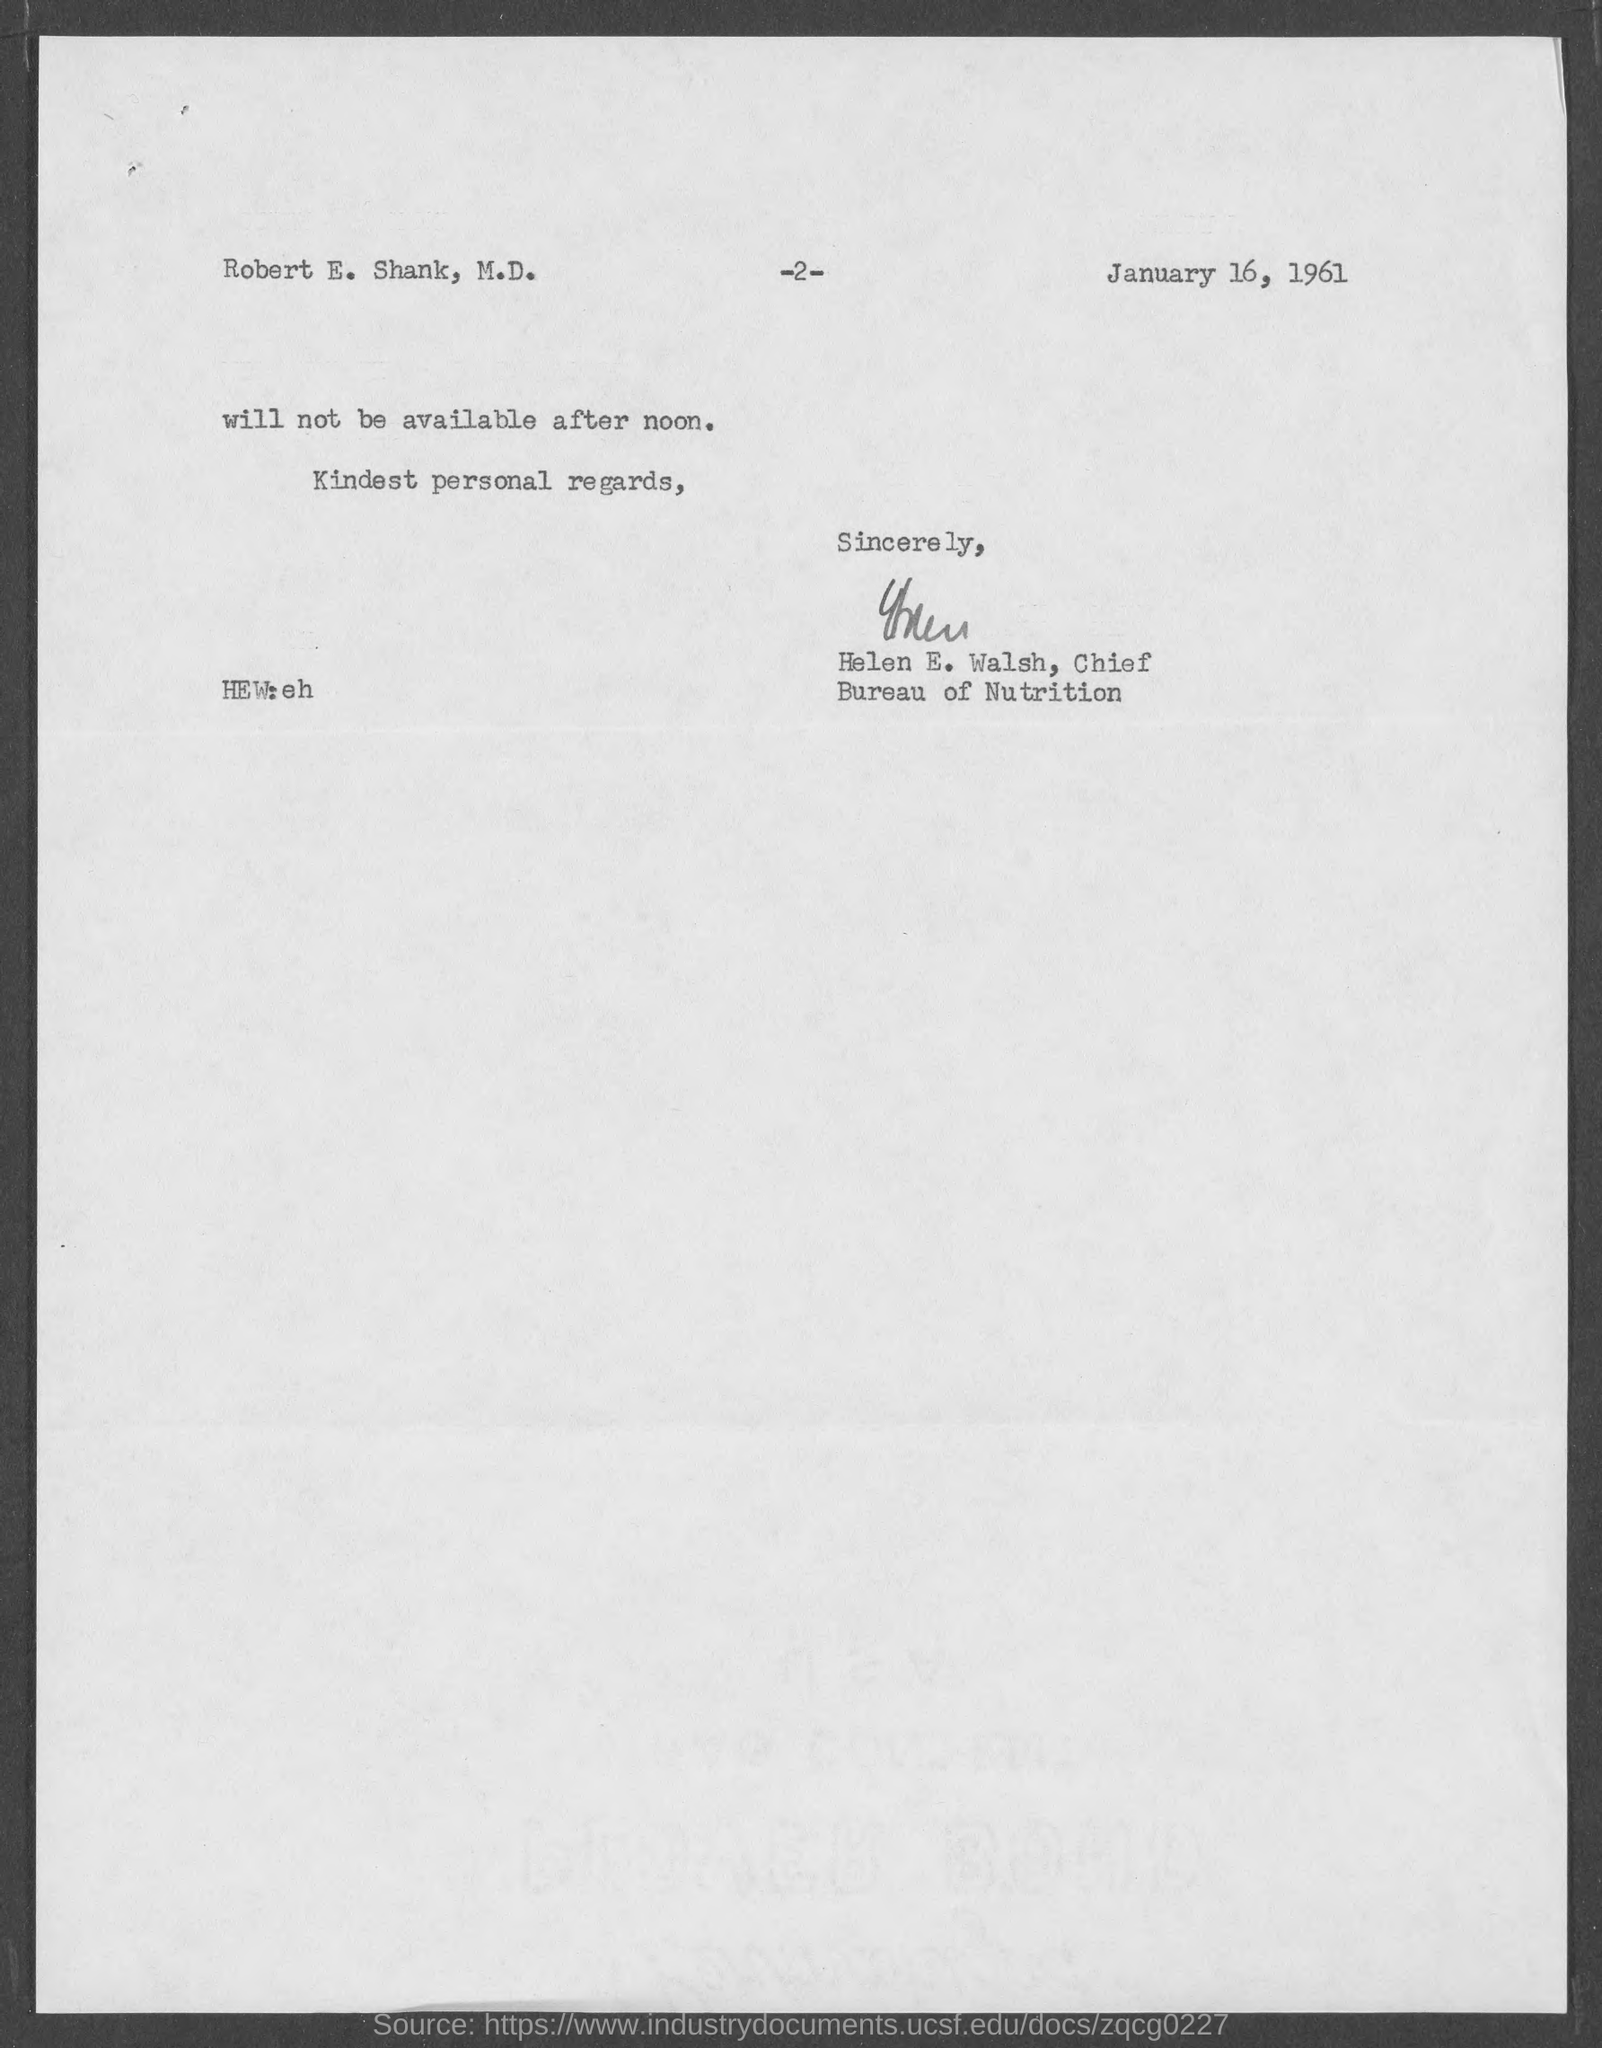What is the date in the document?
Provide a short and direct response. January 16, 1961. To whom is this letter addressed to?
Offer a very short reply. Robert E. Shank, M.D. Who is this letter from?
Offer a terse response. Helen E. Walsh. 